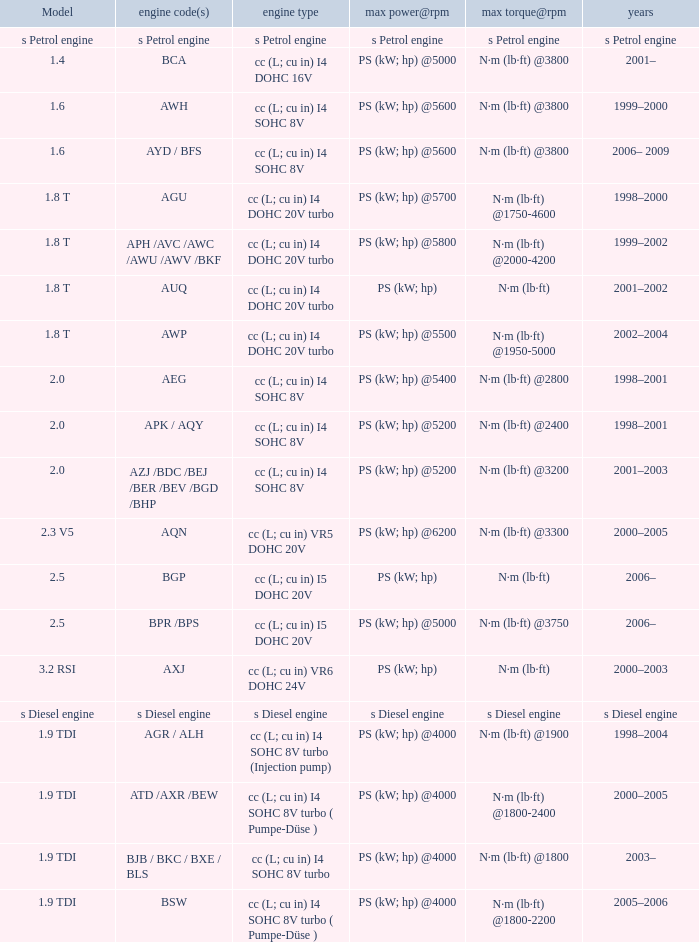What kind of engine was utilized in the model Cc (l; cu in) vr5 dohc 20v. 